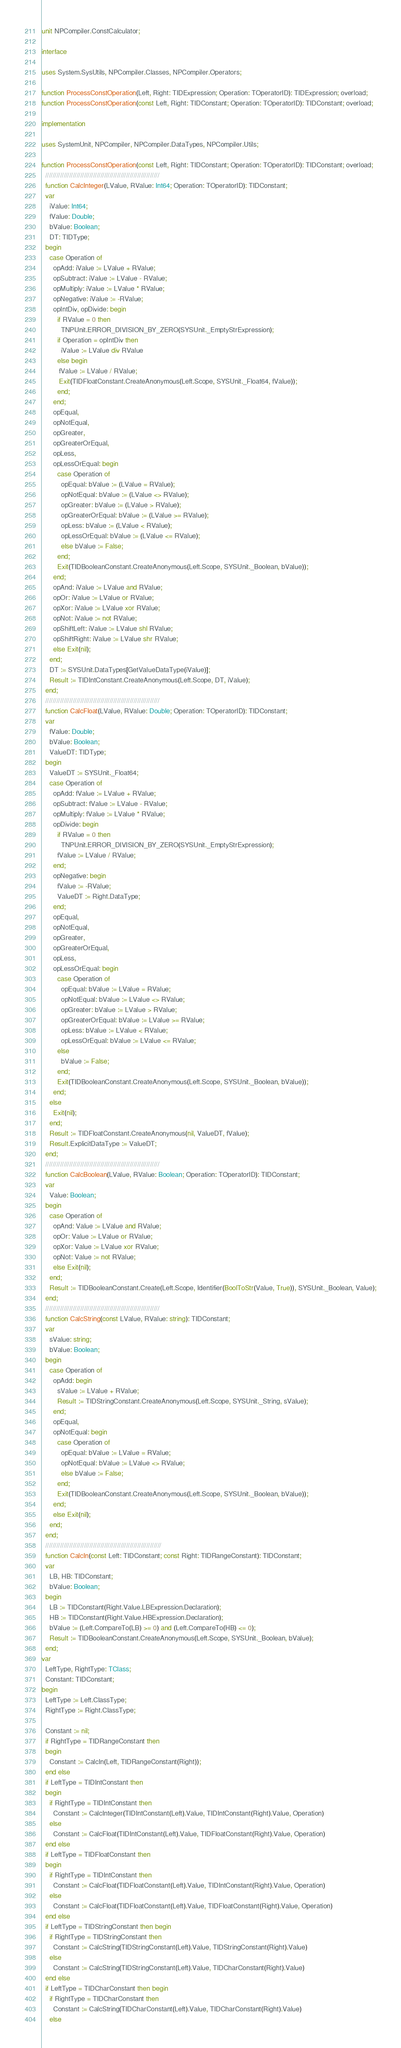<code> <loc_0><loc_0><loc_500><loc_500><_Pascal_>unit NPCompiler.ConstCalculator;

interface

uses System.SysUtils, NPCompiler.Classes, NPCompiler.Operators;

function ProcessConstOperation(Left, Right: TIDExpression; Operation: TOperatorID): TIDExpression; overload;
function ProcessConstOperation(const Left, Right: TIDConstant; Operation: TOperatorID): TIDConstant; overload;

implementation

uses SystemUnit, NPCompiler, NPCompiler.DataTypes, NPCompiler.Utils;

function ProcessConstOperation(const Left, Right: TIDConstant; Operation: TOperatorID): TIDConstant; overload;
  //////////////////////////////////////////////////////////////
  function CalcInteger(LValue, RValue: Int64; Operation: TOperatorID): TIDConstant;
  var
    iValue: Int64;
    fValue: Double;
    bValue: Boolean;
    DT: TIDType;
  begin
    case Operation of
      opAdd: iValue := LValue + RValue;
      opSubtract: iValue := LValue - RValue;
      opMultiply: iValue := LValue * RValue;
      opNegative: iValue := -RValue;
      opIntDiv, opDivide: begin
        if RValue = 0 then
          TNPUnit.ERROR_DIVISION_BY_ZERO(SYSUnit._EmptyStrExpression);
        if Operation = opIntDiv then
          iValue := LValue div RValue
        else begin
         fValue := LValue / RValue;
         Exit(TIDFloatConstant.CreateAnonymous(Left.Scope, SYSUnit._Float64, fValue));
        end;
      end;
      opEqual,
      opNotEqual,
      opGreater,
      opGreaterOrEqual,
      opLess,
      opLessOrEqual: begin
        case Operation of
          opEqual: bValue := (LValue = RValue);
          opNotEqual: bValue := (LValue <> RValue);
          opGreater: bValue := (LValue > RValue);
          opGreaterOrEqual: bValue := (LValue >= RValue);
          opLess: bValue := (LValue < RValue);
          opLessOrEqual: bValue := (LValue <= RValue);
          else bValue := False;
        end;
        Exit(TIDBooleanConstant.CreateAnonymous(Left.Scope, SYSUnit._Boolean, bValue));
      end;
      opAnd: iValue := LValue and RValue;
      opOr: iValue := LValue or RValue;
      opXor: iValue := LValue xor RValue;
      opNot: iValue := not RValue;
      opShiftLeft: iValue := LValue shl RValue;
      opShiftRight: iValue := LValue shr RValue;
      else Exit(nil);
    end;
    DT := SYSUnit.DataTypes[GetValueDataType(iValue)];
    Result := TIDIntConstant.CreateAnonymous(Left.Scope, DT, iValue);
  end;
  //////////////////////////////////////////////////////////////
  function CalcFloat(LValue, RValue: Double; Operation: TOperatorID): TIDConstant;
  var
    fValue: Double;
    bValue: Boolean;
    ValueDT: TIDType;
  begin
    ValueDT := SYSUnit._Float64;
    case Operation of
      opAdd: fValue := LValue + RValue;
      opSubtract: fValue := LValue - RValue;
      opMultiply: fValue := LValue * RValue;
      opDivide: begin
        if RValue = 0 then
          TNPUnit.ERROR_DIVISION_BY_ZERO(SYSUnit._EmptyStrExpression);
        fValue := LValue / RValue;
      end;
      opNegative: begin
        fValue := -RValue;
        ValueDT := Right.DataType;
      end;
      opEqual,
      opNotEqual,
      opGreater,
      opGreaterOrEqual,
      opLess,
      opLessOrEqual: begin
        case Operation of
          opEqual: bValue := LValue = RValue;
          opNotEqual: bValue := LValue <> RValue;
          opGreater: bValue := LValue > RValue;
          opGreaterOrEqual: bValue := LValue >= RValue;
          opLess: bValue := LValue < RValue;
          opLessOrEqual: bValue := LValue <= RValue;
        else
          bValue := False;
        end;
        Exit(TIDBooleanConstant.CreateAnonymous(Left.Scope, SYSUnit._Boolean, bValue));
      end;
    else
      Exit(nil);
    end;
    Result := TIDFloatConstant.CreateAnonymous(nil, ValueDT, fValue);
    Result.ExplicitDataType := ValueDT;
  end;
  //////////////////////////////////////////////////////////////
  function CalcBoolean(LValue, RValue: Boolean; Operation: TOperatorID): TIDConstant;
  var
    Value: Boolean;
  begin
    case Operation of
      opAnd: Value := LValue and RValue;
      opOr: Value := LValue or RValue;
      opXor: Value := LValue xor RValue;
      opNot: Value := not RValue;
      else Exit(nil);
    end;
    Result := TIDBooleanConstant.Create(Left.Scope, Identifier(BoolToStr(Value, True)), SYSUnit._Boolean, Value);
  end;
  //////////////////////////////////////////////////////////////
  function CalcString(const LValue, RValue: string): TIDConstant;
  var
    sValue: string;
    bValue: Boolean;
  begin
    case Operation of
      opAdd: begin
        sValue := LValue + RValue;
        Result := TIDStringConstant.CreateAnonymous(Left.Scope, SYSUnit._String, sValue);
      end;
      opEqual,
      opNotEqual: begin
        case Operation of
          opEqual: bValue := LValue = RValue;
          opNotEqual: bValue := LValue <> RValue;
          else bValue := False;
        end;
        Exit(TIDBooleanConstant.CreateAnonymous(Left.Scope, SYSUnit._Boolean, bValue));
      end;
      else Exit(nil);
    end;
  end;
  ///////////////////////////////////////////////////////////////
  function CalcIn(const Left: TIDConstant; const Right: TIDRangeConstant): TIDConstant;
  var
    LB, HB: TIDConstant;
    bValue: Boolean;
  begin
    LB := TIDConstant(Right.Value.LBExpression.Declaration);
    HB := TIDConstant(Right.Value.HBExpression.Declaration);
    bValue := (Left.CompareTo(LB) >= 0) and (Left.CompareTo(HB) <= 0);
    Result := TIDBooleanConstant.CreateAnonymous(Left.Scope, SYSUnit._Boolean, bValue);
  end;
var
  LeftType, RightType: TClass;
  Constant: TIDConstant;
begin
  LeftType := Left.ClassType;
  RightType := Right.ClassType;

  Constant := nil;
  if RightType = TIDRangeConstant then
  begin
    Constant := CalcIn(Left, TIDRangeConstant(Right));
  end else
  if LeftType = TIDIntConstant then
  begin
    if RightType = TIDIntConstant then
      Constant := CalcInteger(TIDIntConstant(Left).Value, TIDIntConstant(Right).Value, Operation)
    else
      Constant := CalcFloat(TIDIntConstant(Left).Value, TIDFloatConstant(Right).Value, Operation)
  end else
  if LeftType = TIDFloatConstant then
  begin
    if RightType = TIDIntConstant then
      Constant := CalcFloat(TIDFloatConstant(Left).Value, TIDIntConstant(Right).Value, Operation)
    else
      Constant := CalcFloat(TIDFloatConstant(Left).Value, TIDFloatConstant(Right).Value, Operation)
  end else
  if LeftType = TIDStringConstant then begin
    if RightType = TIDStringConstant then
      Constant := CalcString(TIDStringConstant(Left).Value, TIDStringConstant(Right).Value)
    else
      Constant := CalcString(TIDStringConstant(Left).Value, TIDCharConstant(Right).Value)
  end else
  if LeftType = TIDCharConstant then begin
    if RightType = TIDCharConstant then
      Constant := CalcString(TIDCharConstant(Left).Value, TIDCharConstant(Right).Value)
    else</code> 